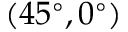Convert formula to latex. <formula><loc_0><loc_0><loc_500><loc_500>( 4 5 ^ { \circ } , 0 ^ { \circ } )</formula> 